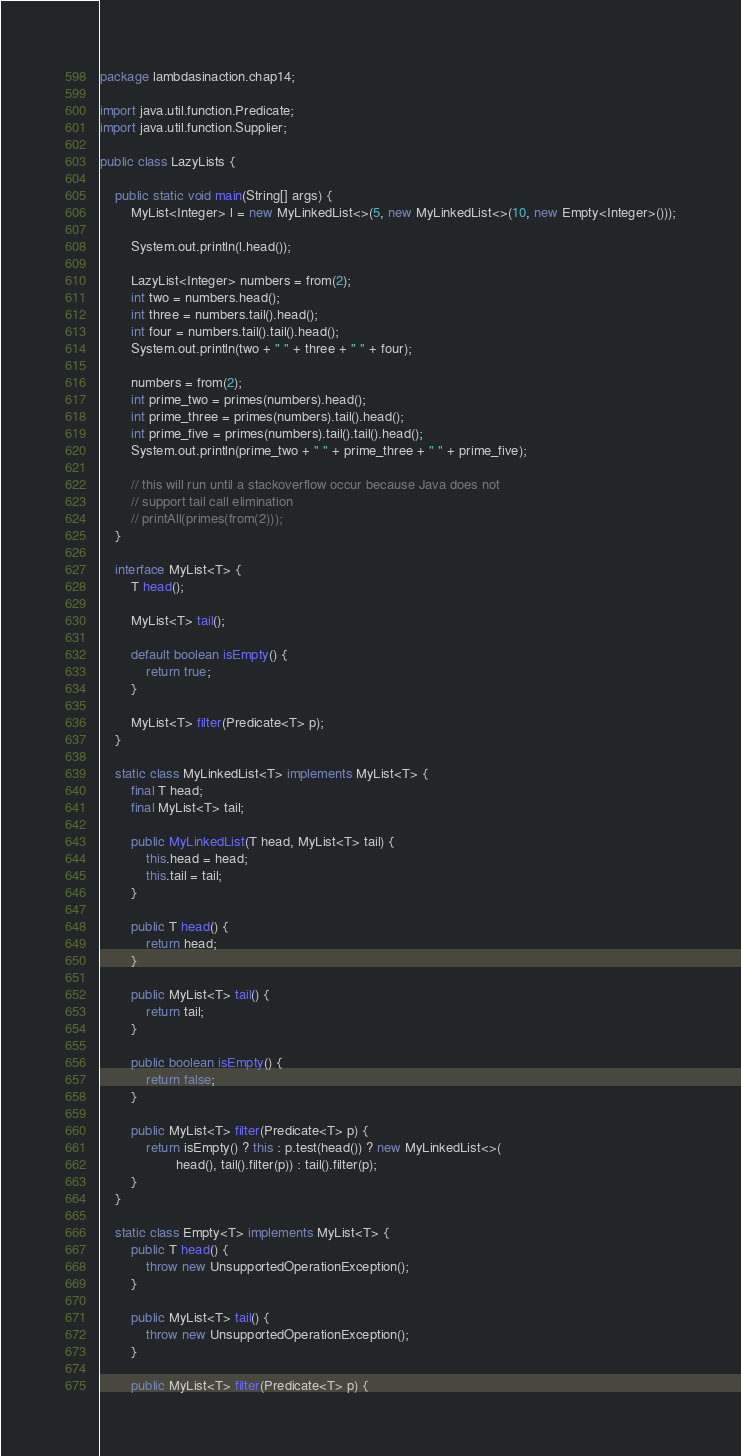Convert code to text. <code><loc_0><loc_0><loc_500><loc_500><_Java_>package lambdasinaction.chap14;

import java.util.function.Predicate;
import java.util.function.Supplier;

public class LazyLists {

    public static void main(String[] args) {
        MyList<Integer> l = new MyLinkedList<>(5, new MyLinkedList<>(10, new Empty<Integer>()));

        System.out.println(l.head());

        LazyList<Integer> numbers = from(2);
        int two = numbers.head();
        int three = numbers.tail().head();
        int four = numbers.tail().tail().head();
        System.out.println(two + " " + three + " " + four);

        numbers = from(2);
        int prime_two = primes(numbers).head();
        int prime_three = primes(numbers).tail().head();
        int prime_five = primes(numbers).tail().tail().head();
        System.out.println(prime_two + " " + prime_three + " " + prime_five);

        // this will run until a stackoverflow occur because Java does not
        // support tail call elimination
        // printAll(primes(from(2)));
    }

    interface MyList<T> {
        T head();

        MyList<T> tail();

        default boolean isEmpty() {
            return true;
        }

        MyList<T> filter(Predicate<T> p);
    }

    static class MyLinkedList<T> implements MyList<T> {
        final T head;
        final MyList<T> tail;

        public MyLinkedList(T head, MyList<T> tail) {
            this.head = head;
            this.tail = tail;
        }

        public T head() {
            return head;
        }

        public MyList<T> tail() {
            return tail;
        }

        public boolean isEmpty() {
            return false;
        }

        public MyList<T> filter(Predicate<T> p) {
            return isEmpty() ? this : p.test(head()) ? new MyLinkedList<>(
                    head(), tail().filter(p)) : tail().filter(p);
        }
    }

    static class Empty<T> implements MyList<T> {
        public T head() {
            throw new UnsupportedOperationException();
        }

        public MyList<T> tail() {
            throw new UnsupportedOperationException();
        }

        public MyList<T> filter(Predicate<T> p) {</code> 